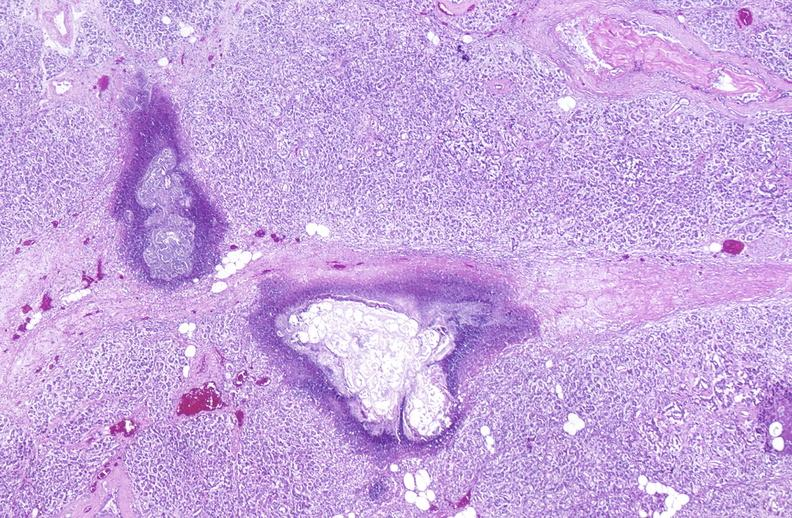what does this image show?
Answer the question using a single word or phrase. Pancreatic fat necrosis 